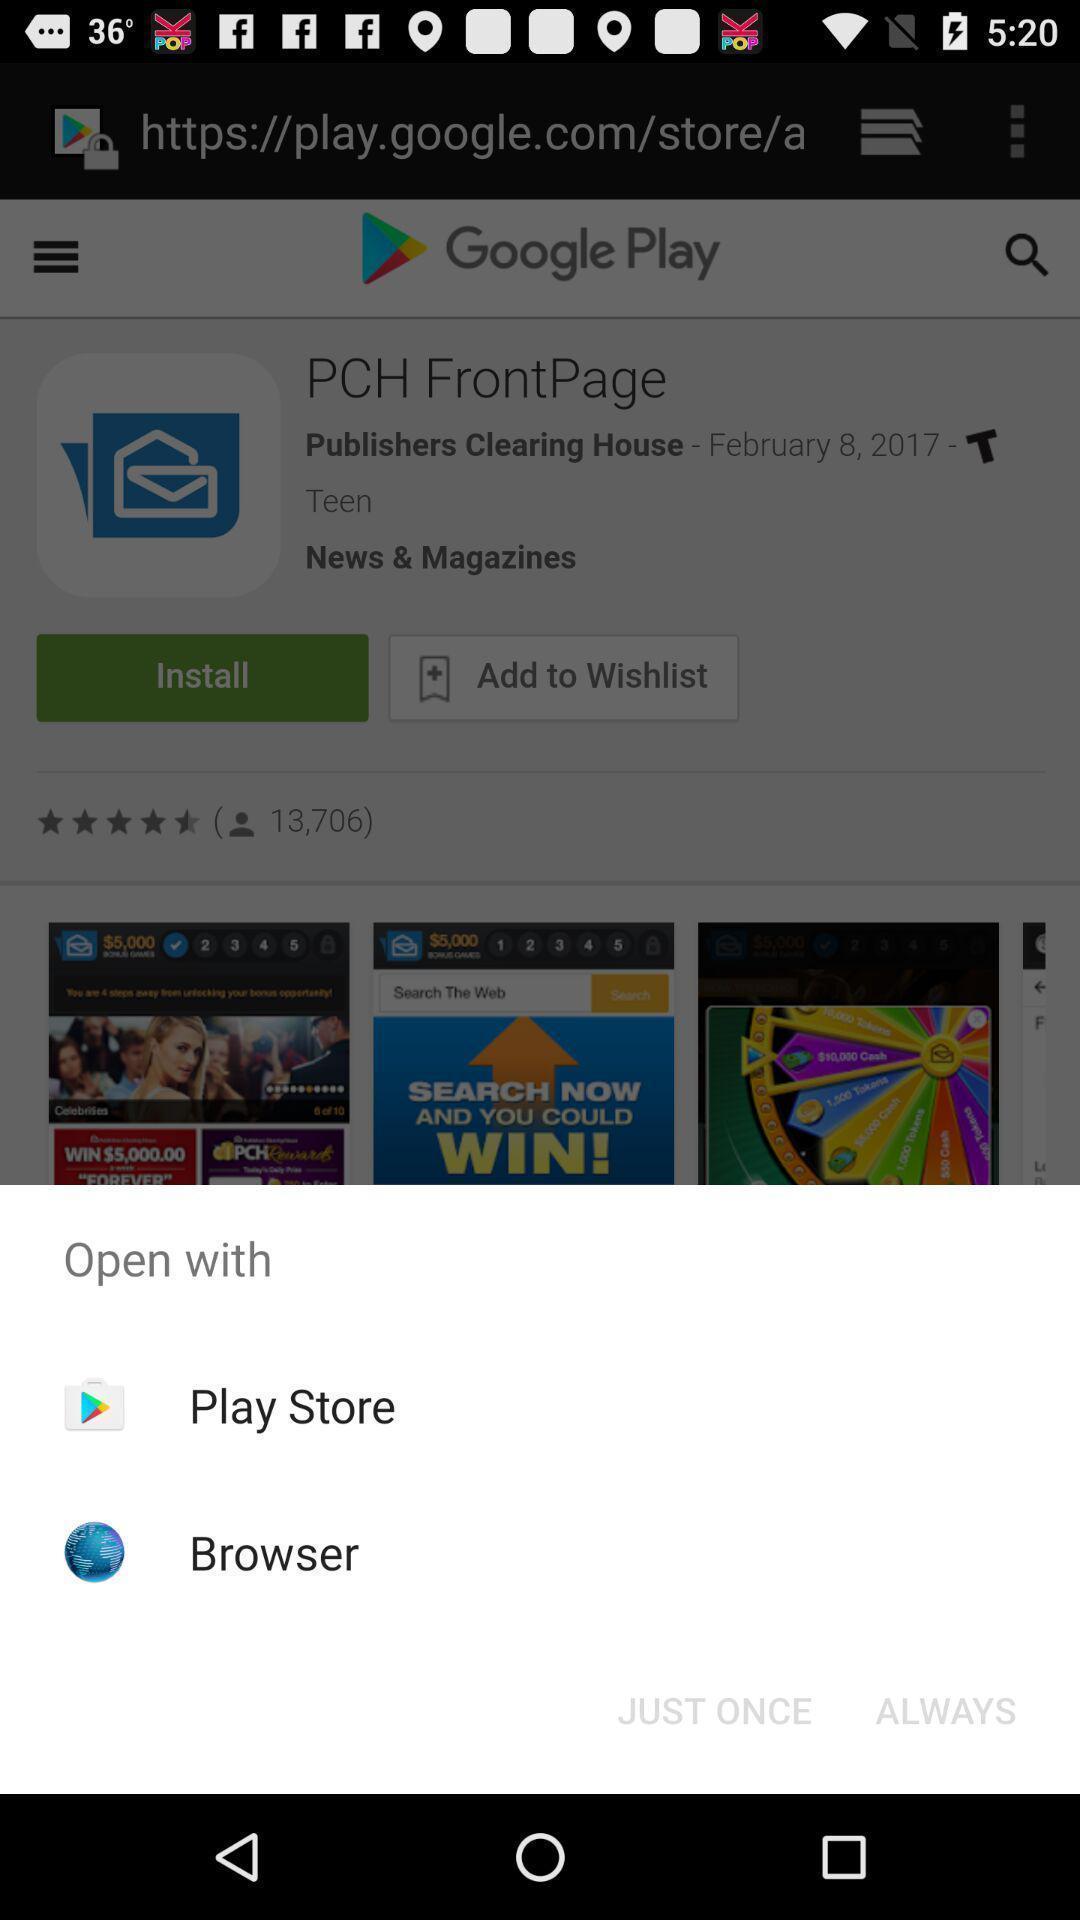Describe the visual elements of this screenshot. Select page through which browser to complete action. 